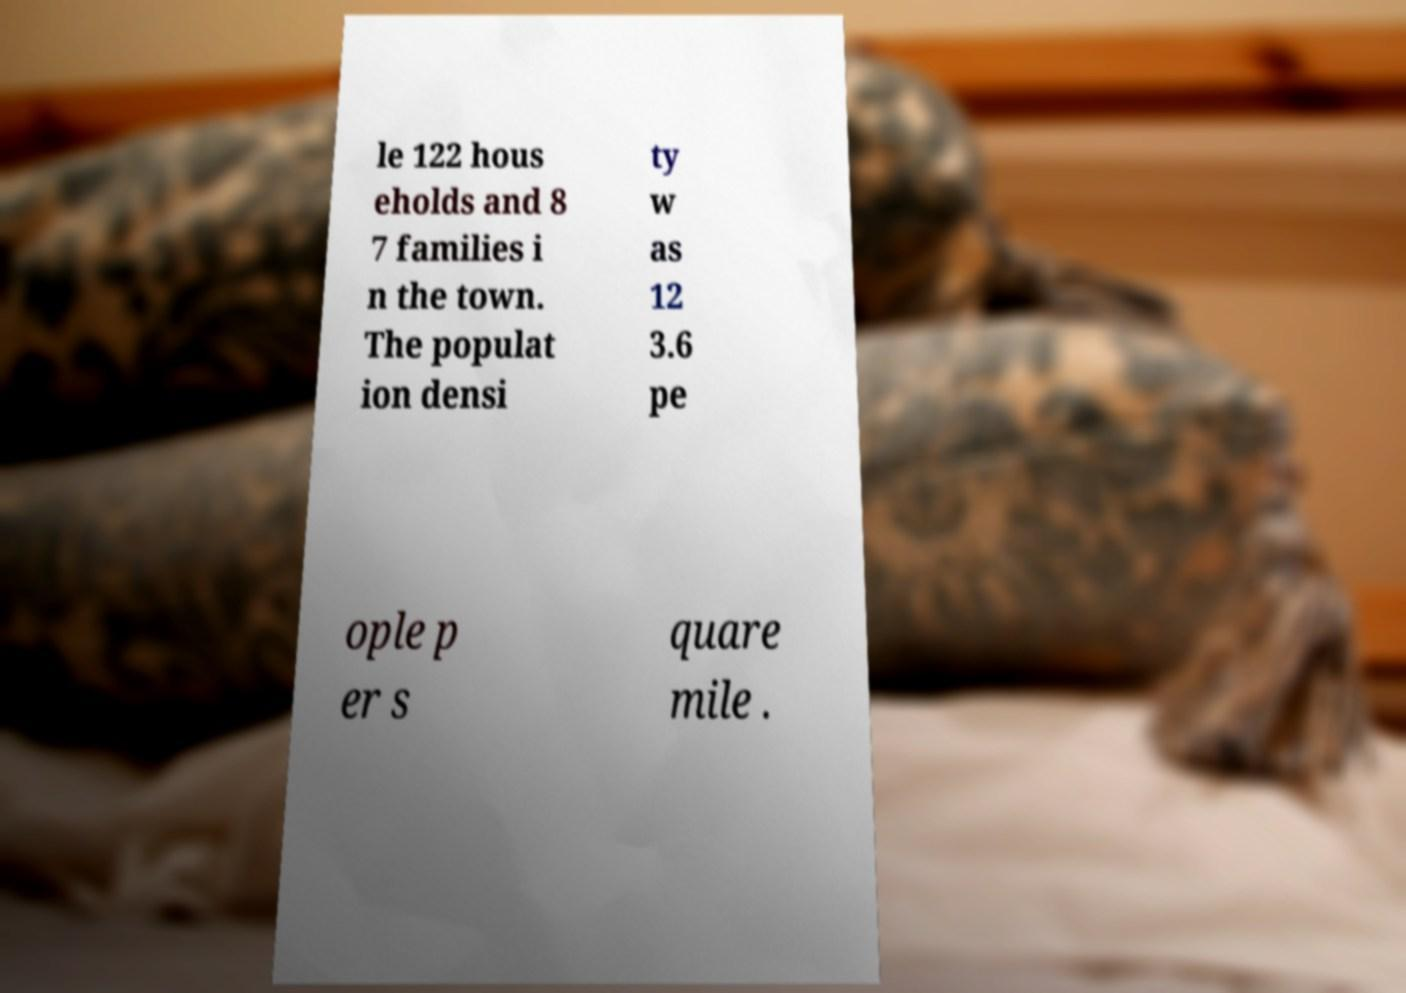Please identify and transcribe the text found in this image. le 122 hous eholds and 8 7 families i n the town. The populat ion densi ty w as 12 3.6 pe ople p er s quare mile . 